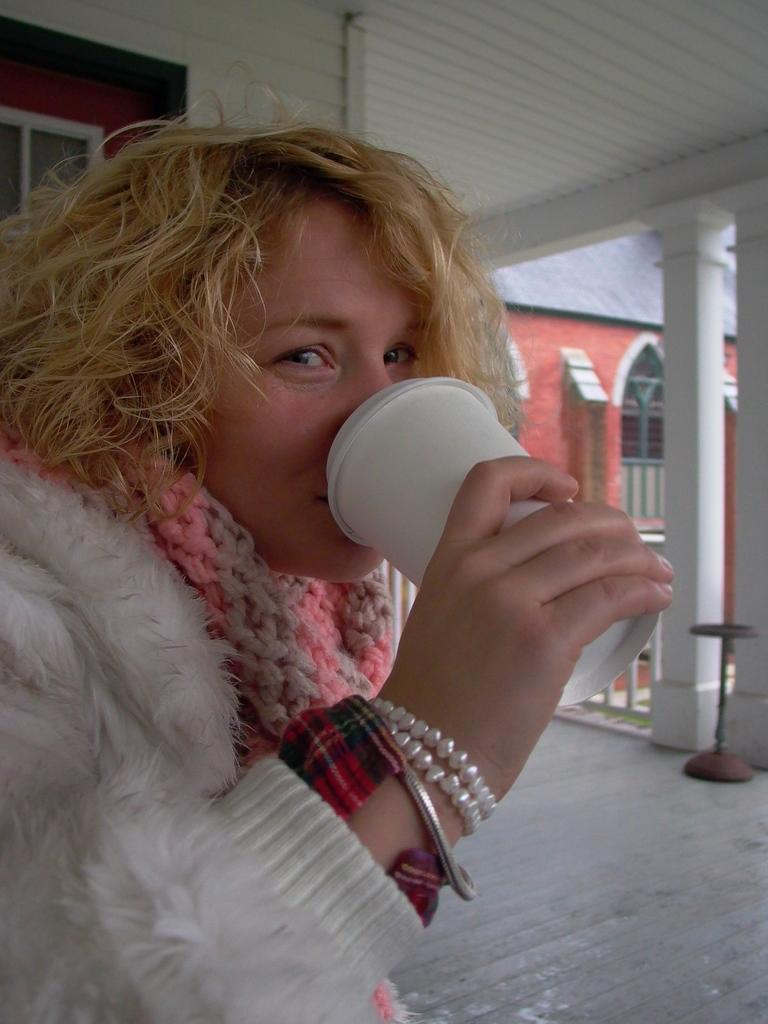What is the person in the image doing? There is a person drinking juice from a cup in the image. What architectural features can be seen on the back side of the image? There are pillars, windows, and a wall visible on the back side of the image. What type of news can be heard coming from the orange in the image? There is no orange present in the image, and therefore no news can be heard coming from it. What is the profit margin of the person drinking juice in the image? There is no information about profit margins in the image, as it focuses on the person drinking juice and the architectural features. 